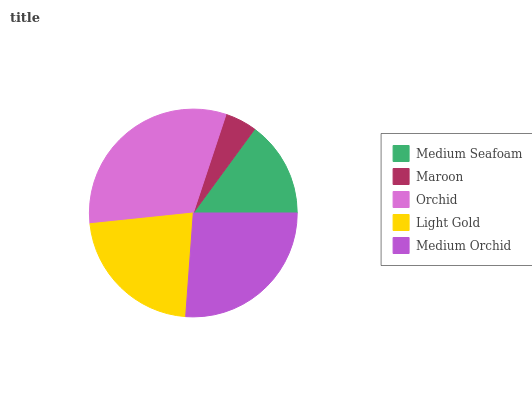Is Maroon the minimum?
Answer yes or no. Yes. Is Orchid the maximum?
Answer yes or no. Yes. Is Orchid the minimum?
Answer yes or no. No. Is Maroon the maximum?
Answer yes or no. No. Is Orchid greater than Maroon?
Answer yes or no. Yes. Is Maroon less than Orchid?
Answer yes or no. Yes. Is Maroon greater than Orchid?
Answer yes or no. No. Is Orchid less than Maroon?
Answer yes or no. No. Is Light Gold the high median?
Answer yes or no. Yes. Is Light Gold the low median?
Answer yes or no. Yes. Is Medium Orchid the high median?
Answer yes or no. No. Is Maroon the low median?
Answer yes or no. No. 